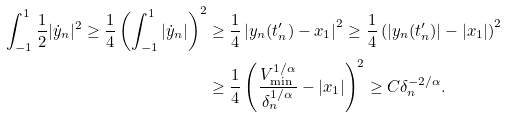Convert formula to latex. <formula><loc_0><loc_0><loc_500><loc_500>\int _ { - 1 } ^ { 1 } \frac { 1 } { 2 } | \dot { y } _ { n } | ^ { 2 } \geq \frac { 1 } { 4 } \left ( \int _ { - 1 } ^ { 1 } | \dot { y } _ { n } | \right ) ^ { 2 } & \geq \frac { 1 } { 4 } \left | y _ { n } ( t _ { n } ^ { \prime } ) - x _ { 1 } \right | ^ { 2 } \geq \frac { 1 } { 4 } \left ( | y _ { n } ( t _ { n } ^ { \prime } ) | - | x _ { 1 } | \right ) ^ { 2 } \\ & \geq \frac { 1 } { 4 } \left ( \frac { V _ { \min } ^ { 1 / \alpha } } { \delta _ { n } ^ { 1 / \alpha } } - | x _ { 1 } | \right ) ^ { 2 } \geq C \delta _ { n } ^ { - 2 / \alpha } .</formula> 